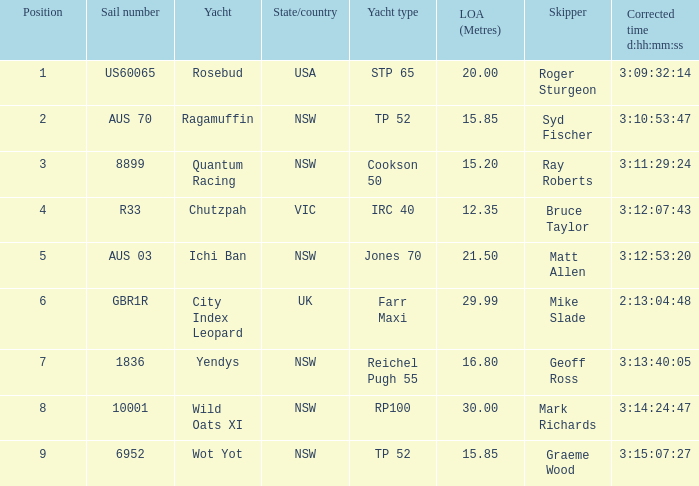What are all sail numbers for the yacht Yendys? 1836.0. 